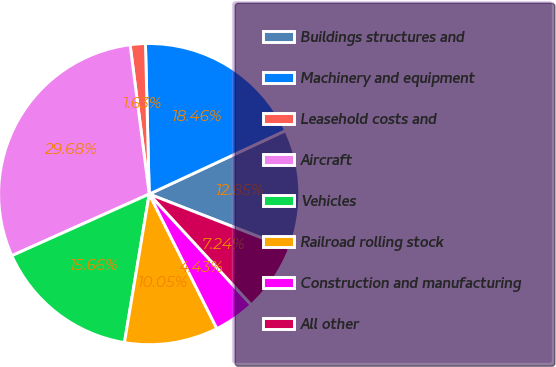Convert chart to OTSL. <chart><loc_0><loc_0><loc_500><loc_500><pie_chart><fcel>Buildings structures and<fcel>Machinery and equipment<fcel>Leasehold costs and<fcel>Aircraft<fcel>Vehicles<fcel>Railroad rolling stock<fcel>Construction and manufacturing<fcel>All other<nl><fcel>12.85%<fcel>18.46%<fcel>1.63%<fcel>29.68%<fcel>15.66%<fcel>10.05%<fcel>4.43%<fcel>7.24%<nl></chart> 